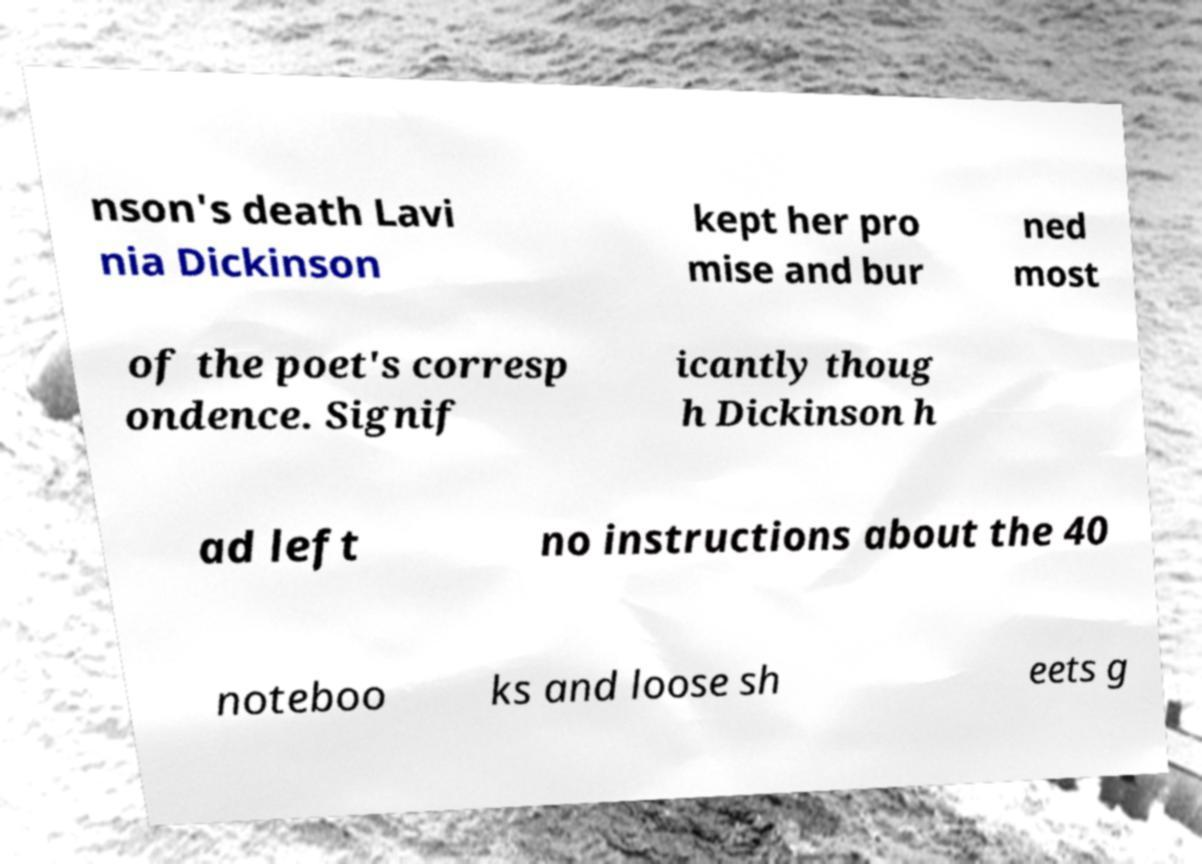There's text embedded in this image that I need extracted. Can you transcribe it verbatim? nson's death Lavi nia Dickinson kept her pro mise and bur ned most of the poet's corresp ondence. Signif icantly thoug h Dickinson h ad left no instructions about the 40 noteboo ks and loose sh eets g 